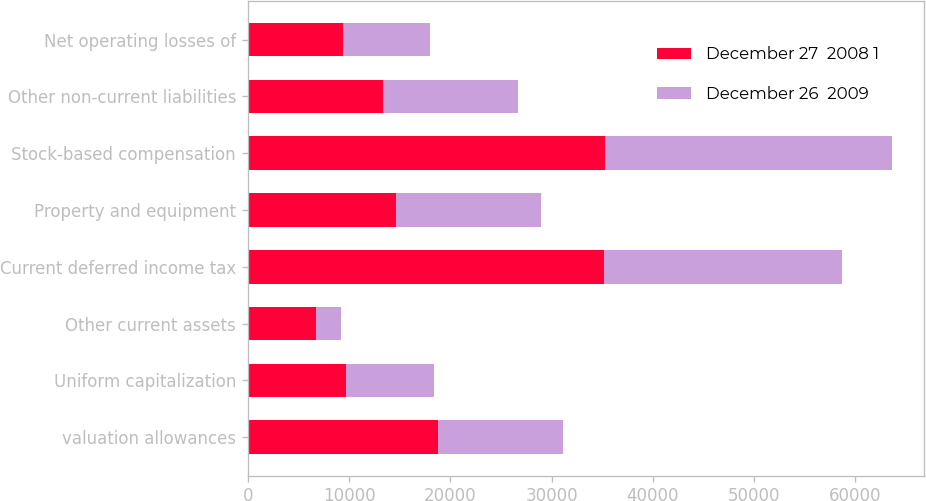Convert chart. <chart><loc_0><loc_0><loc_500><loc_500><stacked_bar_chart><ecel><fcel>valuation allowances<fcel>Uniform capitalization<fcel>Other current assets<fcel>Current deferred income tax<fcel>Property and equipment<fcel>Stock-based compensation<fcel>Other non-current liabilities<fcel>Net operating losses of<nl><fcel>December 27  2008 1<fcel>18734<fcel>9690<fcel>6742<fcel>35166<fcel>14658<fcel>35312<fcel>13334.5<fcel>9411<nl><fcel>December 26  2009<fcel>12348<fcel>8712<fcel>2497<fcel>23557<fcel>14321<fcel>28275<fcel>13334.5<fcel>8537<nl></chart> 